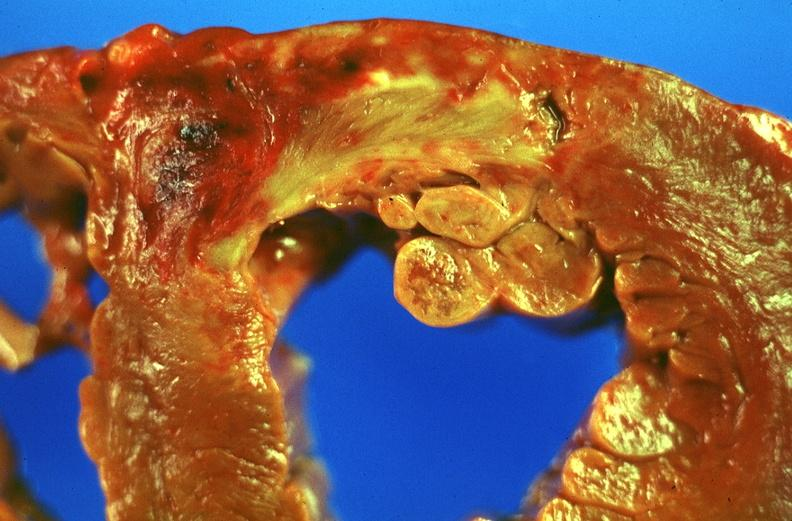what is present?
Answer the question using a single word or phrase. Cardiovascular 